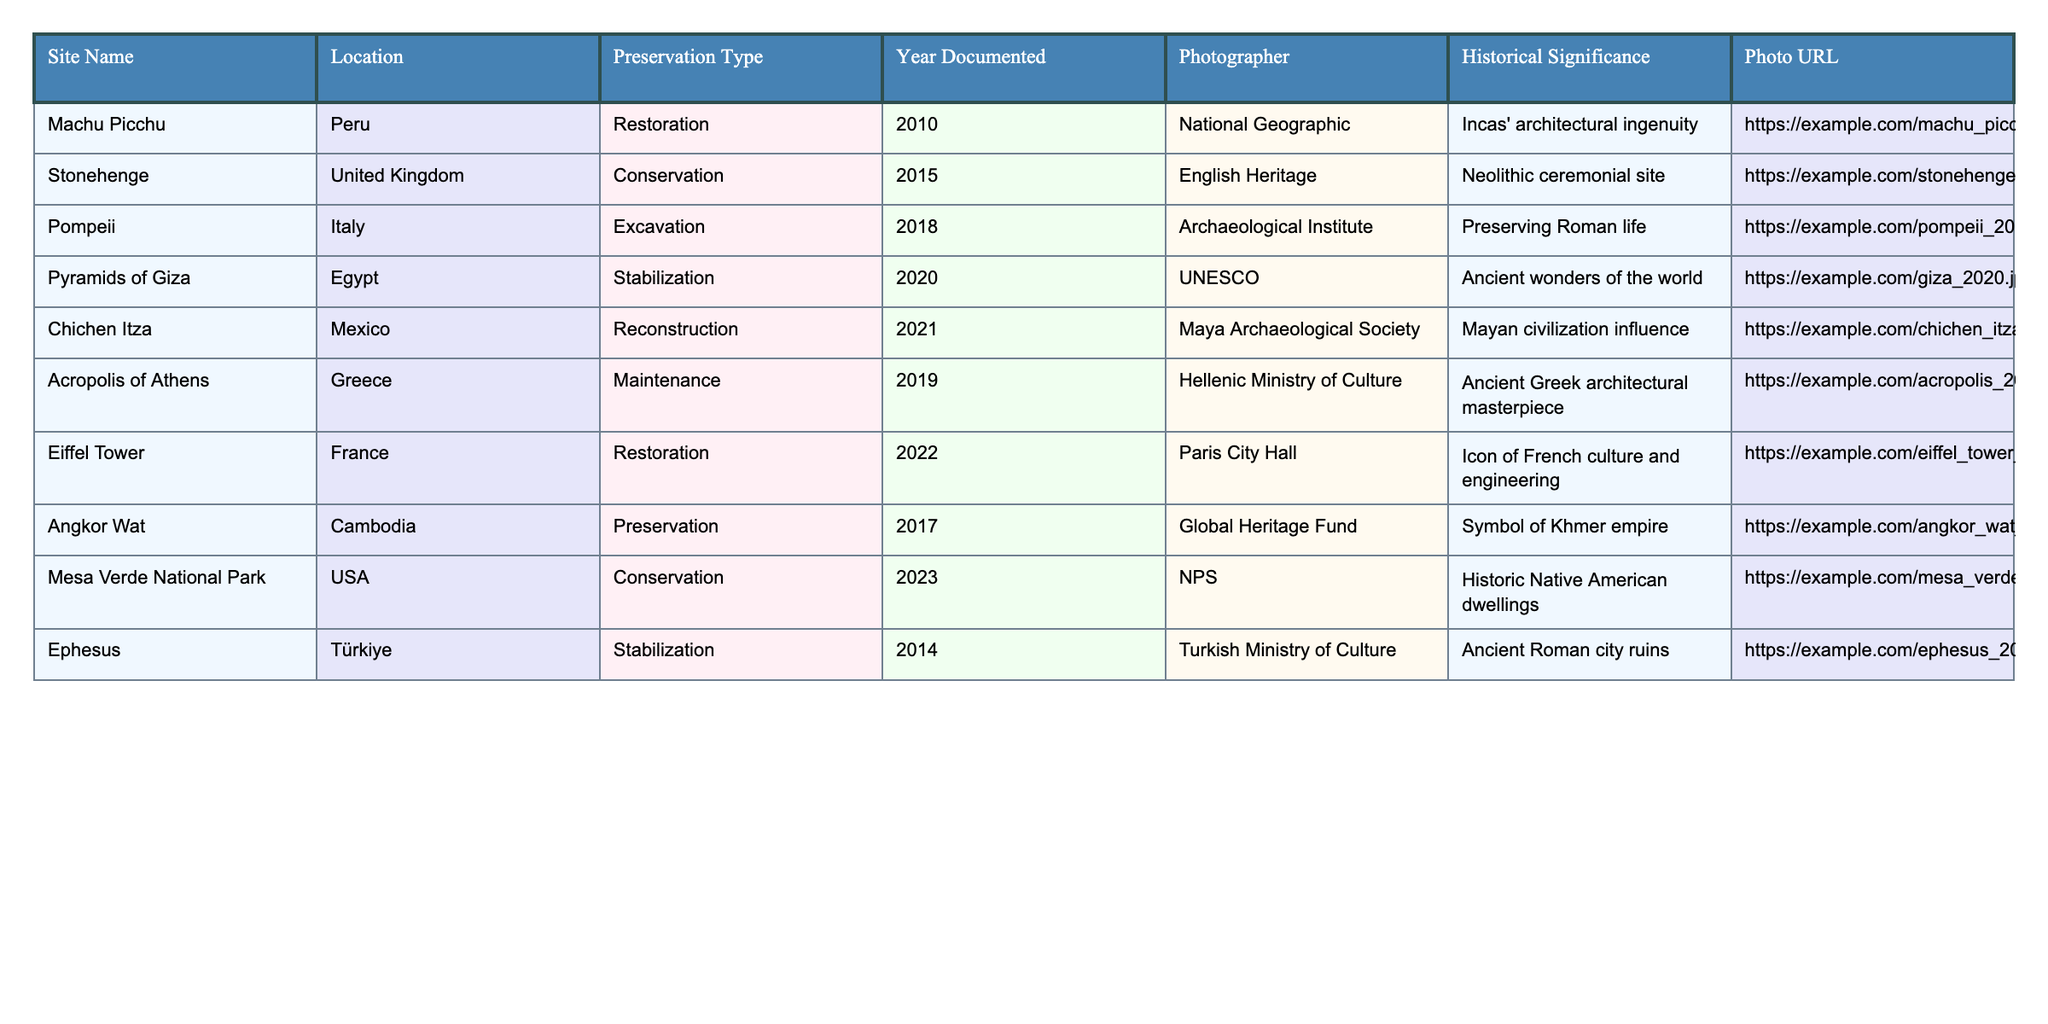What is the preservation type for Machu Picchu? In the table, I locate the row for Machu Picchu and find the value under the "Preservation Type" column, which states "Restoration."
Answer: Restoration Which site was documented in 2019? I look at the "Year Documented" column and find that the row with the year 2019 corresponds to the Acropolis of Athens.
Answer: Acropolis of Athens How many sites were documented after 2018? I count the rows where "Year Documented" is greater than 2018, which includes Chichen Itza (2021), Eiffel Tower (2022), and Mesa Verde National Park (2023), totaling three sites.
Answer: 3 Which site has the earliest documentation year? I review the "Year Documented" column and see that Machu Picchu has the earliest documentation year of 2010 compared to other entries in the table.
Answer: 2010 Is the photographer for the Pyramids of Giza from UNESCO? I check the row for the Pyramids of Giza and confirm that the corresponding photographer is labeled as UNESCO, which confirms the statement.
Answer: Yes What is the historical significance of the site documented in 2014? Locating the row for 2014, I read the "Historical Significance" for Ephesus, which is "Ancient Roman city ruins."
Answer: Ancient Roman city ruins How many sites are linked to the theme of restoration? I review the "Preservation Type" column and find that there are three sites categorized under restoration: Machu Picchu (2010), Eiffel Tower (2022), and another (none in this case). Totaling them gives a count of two.
Answer: 2 Which site represents a symbol of the Khmer empire according to the table? I look through the "Historical Significance" column until I find Angkor Wat, which is specifically noted as a symbol of the Khmer empire.
Answer: Angkor Wat Determine the average year documented for sites in the table. I gather all the years: 2010, 2015, 2018, 2020, 2021, 2019, 2022, 2017, 2023, 2014. Then I find the sum (2010 + 2015 + 2018 + 2020 + 2021 + 2019 + 2022 + 2017 + 2023 + 2014 = 2020) and divide by the number of sites (10), giving 2020/10 = 2020.
Answer: 2020 For which site was the photographer the National Geographic? In the table, under the "Photographer" column, I find that the site listed as having National Geographic is Machu Picchu.
Answer: Machu Picchu 